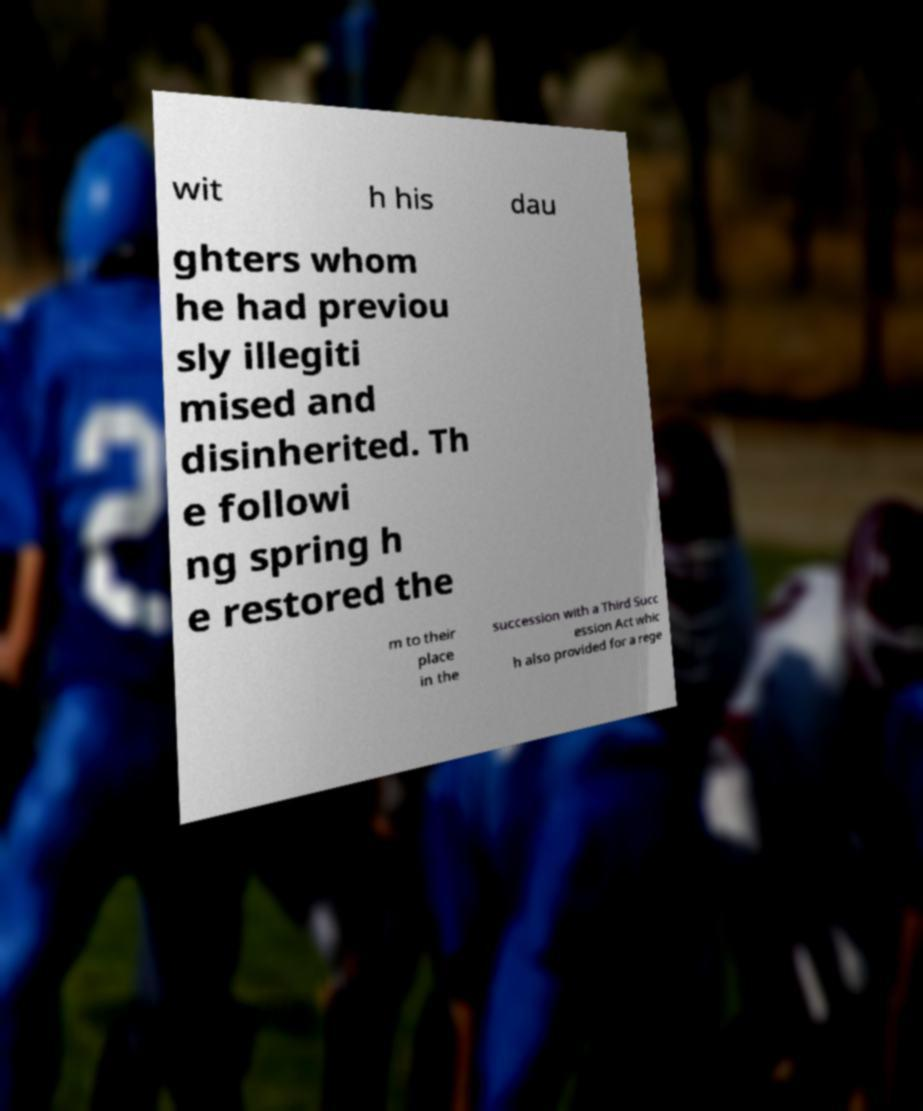Can you accurately transcribe the text from the provided image for me? wit h his dau ghters whom he had previou sly illegiti mised and disinherited. Th e followi ng spring h e restored the m to their place in the succession with a Third Succ ession Act whic h also provided for a rege 